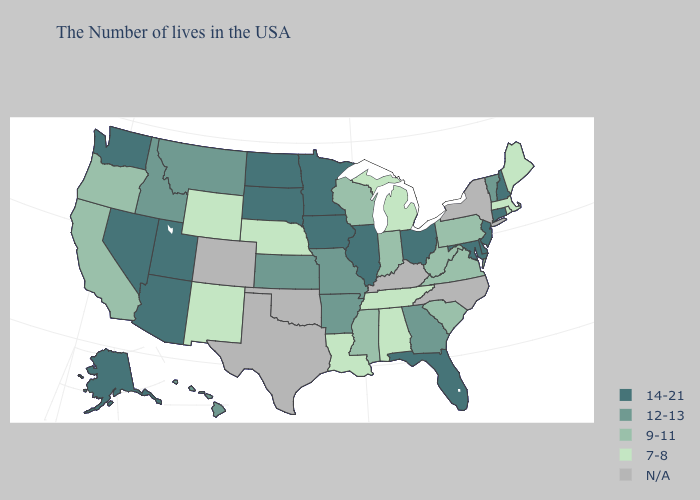What is the value of Maine?
Short answer required. 7-8. Does Oregon have the lowest value in the West?
Short answer required. No. Name the states that have a value in the range 12-13?
Be succinct. Vermont, Georgia, Missouri, Arkansas, Kansas, Montana, Idaho, Hawaii. Name the states that have a value in the range 7-8?
Quick response, please. Maine, Massachusetts, Rhode Island, Michigan, Alabama, Tennessee, Louisiana, Nebraska, Wyoming, New Mexico. What is the lowest value in the USA?
Be succinct. 7-8. Name the states that have a value in the range 14-21?
Quick response, please. New Hampshire, Connecticut, New Jersey, Delaware, Maryland, Ohio, Florida, Illinois, Minnesota, Iowa, South Dakota, North Dakota, Utah, Arizona, Nevada, Washington, Alaska. What is the lowest value in the West?
Be succinct. 7-8. Name the states that have a value in the range 12-13?
Give a very brief answer. Vermont, Georgia, Missouri, Arkansas, Kansas, Montana, Idaho, Hawaii. What is the lowest value in the West?
Give a very brief answer. 7-8. Name the states that have a value in the range 12-13?
Answer briefly. Vermont, Georgia, Missouri, Arkansas, Kansas, Montana, Idaho, Hawaii. What is the value of West Virginia?
Be succinct. 9-11. What is the highest value in the West ?
Concise answer only. 14-21. Name the states that have a value in the range 12-13?
Short answer required. Vermont, Georgia, Missouri, Arkansas, Kansas, Montana, Idaho, Hawaii. Which states have the lowest value in the South?
Be succinct. Alabama, Tennessee, Louisiana. 